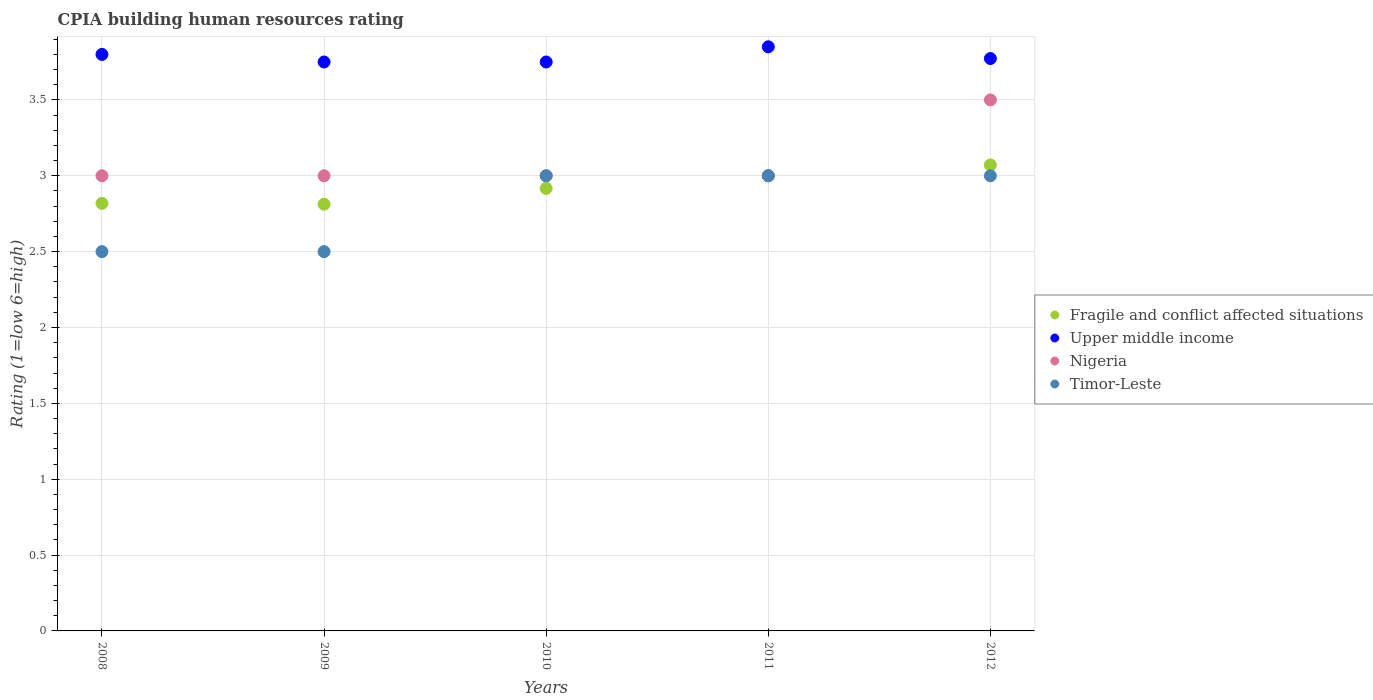How many different coloured dotlines are there?
Offer a very short reply. 4. Across all years, what is the maximum CPIA rating in Fragile and conflict affected situations?
Ensure brevity in your answer.  3.07. In which year was the CPIA rating in Nigeria maximum?
Ensure brevity in your answer.  2012. In which year was the CPIA rating in Timor-Leste minimum?
Your answer should be compact. 2008. What is the difference between the CPIA rating in Upper middle income in 2010 and that in 2012?
Your answer should be compact. -0.02. What is the average CPIA rating in Fragile and conflict affected situations per year?
Your response must be concise. 2.92. In the year 2010, what is the difference between the CPIA rating in Fragile and conflict affected situations and CPIA rating in Timor-Leste?
Provide a short and direct response. -0.08. In how many years, is the CPIA rating in Timor-Leste greater than 1.1?
Make the answer very short. 5. What is the ratio of the CPIA rating in Upper middle income in 2008 to that in 2009?
Provide a succinct answer. 1.01. Is the CPIA rating in Upper middle income in 2009 less than that in 2010?
Ensure brevity in your answer.  No. Is the difference between the CPIA rating in Fragile and conflict affected situations in 2009 and 2011 greater than the difference between the CPIA rating in Timor-Leste in 2009 and 2011?
Your response must be concise. Yes. What is the difference between the highest and the second highest CPIA rating in Fragile and conflict affected situations?
Provide a short and direct response. 0.07. Is it the case that in every year, the sum of the CPIA rating in Upper middle income and CPIA rating in Nigeria  is greater than the sum of CPIA rating in Fragile and conflict affected situations and CPIA rating in Timor-Leste?
Keep it short and to the point. Yes. Is it the case that in every year, the sum of the CPIA rating in Fragile and conflict affected situations and CPIA rating in Nigeria  is greater than the CPIA rating in Timor-Leste?
Provide a short and direct response. Yes. Is the CPIA rating in Upper middle income strictly less than the CPIA rating in Fragile and conflict affected situations over the years?
Ensure brevity in your answer.  No. What is the difference between two consecutive major ticks on the Y-axis?
Provide a short and direct response. 0.5. Does the graph contain grids?
Offer a very short reply. Yes. Where does the legend appear in the graph?
Offer a very short reply. Center right. How are the legend labels stacked?
Your answer should be compact. Vertical. What is the title of the graph?
Ensure brevity in your answer.  CPIA building human resources rating. What is the Rating (1=low 6=high) in Fragile and conflict affected situations in 2008?
Offer a terse response. 2.82. What is the Rating (1=low 6=high) in Nigeria in 2008?
Provide a short and direct response. 3. What is the Rating (1=low 6=high) of Fragile and conflict affected situations in 2009?
Make the answer very short. 2.81. What is the Rating (1=low 6=high) in Upper middle income in 2009?
Offer a very short reply. 3.75. What is the Rating (1=low 6=high) in Nigeria in 2009?
Offer a terse response. 3. What is the Rating (1=low 6=high) in Timor-Leste in 2009?
Provide a short and direct response. 2.5. What is the Rating (1=low 6=high) in Fragile and conflict affected situations in 2010?
Provide a succinct answer. 2.92. What is the Rating (1=low 6=high) of Upper middle income in 2010?
Offer a very short reply. 3.75. What is the Rating (1=low 6=high) of Nigeria in 2010?
Your response must be concise. 3. What is the Rating (1=low 6=high) of Fragile and conflict affected situations in 2011?
Your answer should be very brief. 3. What is the Rating (1=low 6=high) of Upper middle income in 2011?
Give a very brief answer. 3.85. What is the Rating (1=low 6=high) in Nigeria in 2011?
Ensure brevity in your answer.  3. What is the Rating (1=low 6=high) in Fragile and conflict affected situations in 2012?
Provide a short and direct response. 3.07. What is the Rating (1=low 6=high) in Upper middle income in 2012?
Provide a succinct answer. 3.77. What is the Rating (1=low 6=high) in Nigeria in 2012?
Keep it short and to the point. 3.5. What is the Rating (1=low 6=high) in Timor-Leste in 2012?
Keep it short and to the point. 3. Across all years, what is the maximum Rating (1=low 6=high) of Fragile and conflict affected situations?
Ensure brevity in your answer.  3.07. Across all years, what is the maximum Rating (1=low 6=high) in Upper middle income?
Provide a short and direct response. 3.85. Across all years, what is the minimum Rating (1=low 6=high) in Fragile and conflict affected situations?
Keep it short and to the point. 2.81. Across all years, what is the minimum Rating (1=low 6=high) in Upper middle income?
Make the answer very short. 3.75. What is the total Rating (1=low 6=high) in Fragile and conflict affected situations in the graph?
Offer a terse response. 14.62. What is the total Rating (1=low 6=high) of Upper middle income in the graph?
Offer a very short reply. 18.92. What is the total Rating (1=low 6=high) of Timor-Leste in the graph?
Provide a short and direct response. 14. What is the difference between the Rating (1=low 6=high) of Fragile and conflict affected situations in 2008 and that in 2009?
Make the answer very short. 0.01. What is the difference between the Rating (1=low 6=high) of Timor-Leste in 2008 and that in 2009?
Your answer should be very brief. 0. What is the difference between the Rating (1=low 6=high) of Fragile and conflict affected situations in 2008 and that in 2010?
Your answer should be very brief. -0.1. What is the difference between the Rating (1=low 6=high) of Timor-Leste in 2008 and that in 2010?
Offer a very short reply. -0.5. What is the difference between the Rating (1=low 6=high) in Fragile and conflict affected situations in 2008 and that in 2011?
Make the answer very short. -0.18. What is the difference between the Rating (1=low 6=high) in Upper middle income in 2008 and that in 2011?
Keep it short and to the point. -0.05. What is the difference between the Rating (1=low 6=high) in Nigeria in 2008 and that in 2011?
Give a very brief answer. 0. What is the difference between the Rating (1=low 6=high) in Fragile and conflict affected situations in 2008 and that in 2012?
Your response must be concise. -0.25. What is the difference between the Rating (1=low 6=high) in Upper middle income in 2008 and that in 2012?
Your response must be concise. 0.03. What is the difference between the Rating (1=low 6=high) of Nigeria in 2008 and that in 2012?
Offer a terse response. -0.5. What is the difference between the Rating (1=low 6=high) of Timor-Leste in 2008 and that in 2012?
Ensure brevity in your answer.  -0.5. What is the difference between the Rating (1=low 6=high) in Fragile and conflict affected situations in 2009 and that in 2010?
Offer a very short reply. -0.1. What is the difference between the Rating (1=low 6=high) in Fragile and conflict affected situations in 2009 and that in 2011?
Your answer should be compact. -0.19. What is the difference between the Rating (1=low 6=high) of Upper middle income in 2009 and that in 2011?
Provide a short and direct response. -0.1. What is the difference between the Rating (1=low 6=high) in Nigeria in 2009 and that in 2011?
Your answer should be very brief. 0. What is the difference between the Rating (1=low 6=high) in Timor-Leste in 2009 and that in 2011?
Your response must be concise. -0.5. What is the difference between the Rating (1=low 6=high) in Fragile and conflict affected situations in 2009 and that in 2012?
Your answer should be very brief. -0.26. What is the difference between the Rating (1=low 6=high) in Upper middle income in 2009 and that in 2012?
Your answer should be very brief. -0.02. What is the difference between the Rating (1=low 6=high) in Fragile and conflict affected situations in 2010 and that in 2011?
Make the answer very short. -0.08. What is the difference between the Rating (1=low 6=high) of Upper middle income in 2010 and that in 2011?
Your answer should be compact. -0.1. What is the difference between the Rating (1=low 6=high) in Nigeria in 2010 and that in 2011?
Give a very brief answer. 0. What is the difference between the Rating (1=low 6=high) of Timor-Leste in 2010 and that in 2011?
Make the answer very short. 0. What is the difference between the Rating (1=low 6=high) of Fragile and conflict affected situations in 2010 and that in 2012?
Keep it short and to the point. -0.15. What is the difference between the Rating (1=low 6=high) of Upper middle income in 2010 and that in 2012?
Your answer should be compact. -0.02. What is the difference between the Rating (1=low 6=high) in Timor-Leste in 2010 and that in 2012?
Make the answer very short. 0. What is the difference between the Rating (1=low 6=high) of Fragile and conflict affected situations in 2011 and that in 2012?
Your answer should be very brief. -0.07. What is the difference between the Rating (1=low 6=high) of Upper middle income in 2011 and that in 2012?
Offer a terse response. 0.08. What is the difference between the Rating (1=low 6=high) in Timor-Leste in 2011 and that in 2012?
Your response must be concise. 0. What is the difference between the Rating (1=low 6=high) of Fragile and conflict affected situations in 2008 and the Rating (1=low 6=high) of Upper middle income in 2009?
Provide a short and direct response. -0.93. What is the difference between the Rating (1=low 6=high) of Fragile and conflict affected situations in 2008 and the Rating (1=low 6=high) of Nigeria in 2009?
Offer a very short reply. -0.18. What is the difference between the Rating (1=low 6=high) of Fragile and conflict affected situations in 2008 and the Rating (1=low 6=high) of Timor-Leste in 2009?
Offer a terse response. 0.32. What is the difference between the Rating (1=low 6=high) of Nigeria in 2008 and the Rating (1=low 6=high) of Timor-Leste in 2009?
Provide a short and direct response. 0.5. What is the difference between the Rating (1=low 6=high) in Fragile and conflict affected situations in 2008 and the Rating (1=low 6=high) in Upper middle income in 2010?
Offer a very short reply. -0.93. What is the difference between the Rating (1=low 6=high) in Fragile and conflict affected situations in 2008 and the Rating (1=low 6=high) in Nigeria in 2010?
Provide a succinct answer. -0.18. What is the difference between the Rating (1=low 6=high) of Fragile and conflict affected situations in 2008 and the Rating (1=low 6=high) of Timor-Leste in 2010?
Ensure brevity in your answer.  -0.18. What is the difference between the Rating (1=low 6=high) of Upper middle income in 2008 and the Rating (1=low 6=high) of Nigeria in 2010?
Your answer should be very brief. 0.8. What is the difference between the Rating (1=low 6=high) of Nigeria in 2008 and the Rating (1=low 6=high) of Timor-Leste in 2010?
Make the answer very short. 0. What is the difference between the Rating (1=low 6=high) in Fragile and conflict affected situations in 2008 and the Rating (1=low 6=high) in Upper middle income in 2011?
Give a very brief answer. -1.03. What is the difference between the Rating (1=low 6=high) of Fragile and conflict affected situations in 2008 and the Rating (1=low 6=high) of Nigeria in 2011?
Provide a succinct answer. -0.18. What is the difference between the Rating (1=low 6=high) of Fragile and conflict affected situations in 2008 and the Rating (1=low 6=high) of Timor-Leste in 2011?
Ensure brevity in your answer.  -0.18. What is the difference between the Rating (1=low 6=high) of Nigeria in 2008 and the Rating (1=low 6=high) of Timor-Leste in 2011?
Ensure brevity in your answer.  0. What is the difference between the Rating (1=low 6=high) in Fragile and conflict affected situations in 2008 and the Rating (1=low 6=high) in Upper middle income in 2012?
Your answer should be very brief. -0.95. What is the difference between the Rating (1=low 6=high) in Fragile and conflict affected situations in 2008 and the Rating (1=low 6=high) in Nigeria in 2012?
Provide a short and direct response. -0.68. What is the difference between the Rating (1=low 6=high) in Fragile and conflict affected situations in 2008 and the Rating (1=low 6=high) in Timor-Leste in 2012?
Offer a terse response. -0.18. What is the difference between the Rating (1=low 6=high) of Upper middle income in 2008 and the Rating (1=low 6=high) of Timor-Leste in 2012?
Offer a terse response. 0.8. What is the difference between the Rating (1=low 6=high) in Fragile and conflict affected situations in 2009 and the Rating (1=low 6=high) in Upper middle income in 2010?
Ensure brevity in your answer.  -0.94. What is the difference between the Rating (1=low 6=high) of Fragile and conflict affected situations in 2009 and the Rating (1=low 6=high) of Nigeria in 2010?
Provide a succinct answer. -0.19. What is the difference between the Rating (1=low 6=high) of Fragile and conflict affected situations in 2009 and the Rating (1=low 6=high) of Timor-Leste in 2010?
Your answer should be very brief. -0.19. What is the difference between the Rating (1=low 6=high) in Upper middle income in 2009 and the Rating (1=low 6=high) in Timor-Leste in 2010?
Provide a short and direct response. 0.75. What is the difference between the Rating (1=low 6=high) in Fragile and conflict affected situations in 2009 and the Rating (1=low 6=high) in Upper middle income in 2011?
Offer a terse response. -1.04. What is the difference between the Rating (1=low 6=high) of Fragile and conflict affected situations in 2009 and the Rating (1=low 6=high) of Nigeria in 2011?
Offer a terse response. -0.19. What is the difference between the Rating (1=low 6=high) of Fragile and conflict affected situations in 2009 and the Rating (1=low 6=high) of Timor-Leste in 2011?
Offer a very short reply. -0.19. What is the difference between the Rating (1=low 6=high) in Upper middle income in 2009 and the Rating (1=low 6=high) in Nigeria in 2011?
Make the answer very short. 0.75. What is the difference between the Rating (1=low 6=high) in Nigeria in 2009 and the Rating (1=low 6=high) in Timor-Leste in 2011?
Give a very brief answer. 0. What is the difference between the Rating (1=low 6=high) in Fragile and conflict affected situations in 2009 and the Rating (1=low 6=high) in Upper middle income in 2012?
Ensure brevity in your answer.  -0.96. What is the difference between the Rating (1=low 6=high) of Fragile and conflict affected situations in 2009 and the Rating (1=low 6=high) of Nigeria in 2012?
Provide a succinct answer. -0.69. What is the difference between the Rating (1=low 6=high) of Fragile and conflict affected situations in 2009 and the Rating (1=low 6=high) of Timor-Leste in 2012?
Your response must be concise. -0.19. What is the difference between the Rating (1=low 6=high) in Upper middle income in 2009 and the Rating (1=low 6=high) in Timor-Leste in 2012?
Keep it short and to the point. 0.75. What is the difference between the Rating (1=low 6=high) of Nigeria in 2009 and the Rating (1=low 6=high) of Timor-Leste in 2012?
Provide a succinct answer. 0. What is the difference between the Rating (1=low 6=high) in Fragile and conflict affected situations in 2010 and the Rating (1=low 6=high) in Upper middle income in 2011?
Your answer should be compact. -0.93. What is the difference between the Rating (1=low 6=high) in Fragile and conflict affected situations in 2010 and the Rating (1=low 6=high) in Nigeria in 2011?
Ensure brevity in your answer.  -0.08. What is the difference between the Rating (1=low 6=high) of Fragile and conflict affected situations in 2010 and the Rating (1=low 6=high) of Timor-Leste in 2011?
Your answer should be compact. -0.08. What is the difference between the Rating (1=low 6=high) of Upper middle income in 2010 and the Rating (1=low 6=high) of Nigeria in 2011?
Offer a terse response. 0.75. What is the difference between the Rating (1=low 6=high) in Nigeria in 2010 and the Rating (1=low 6=high) in Timor-Leste in 2011?
Provide a succinct answer. 0. What is the difference between the Rating (1=low 6=high) of Fragile and conflict affected situations in 2010 and the Rating (1=low 6=high) of Upper middle income in 2012?
Ensure brevity in your answer.  -0.86. What is the difference between the Rating (1=low 6=high) in Fragile and conflict affected situations in 2010 and the Rating (1=low 6=high) in Nigeria in 2012?
Keep it short and to the point. -0.58. What is the difference between the Rating (1=low 6=high) in Fragile and conflict affected situations in 2010 and the Rating (1=low 6=high) in Timor-Leste in 2012?
Offer a terse response. -0.08. What is the difference between the Rating (1=low 6=high) of Upper middle income in 2010 and the Rating (1=low 6=high) of Nigeria in 2012?
Your answer should be very brief. 0.25. What is the difference between the Rating (1=low 6=high) of Nigeria in 2010 and the Rating (1=low 6=high) of Timor-Leste in 2012?
Your response must be concise. 0. What is the difference between the Rating (1=low 6=high) in Fragile and conflict affected situations in 2011 and the Rating (1=low 6=high) in Upper middle income in 2012?
Give a very brief answer. -0.77. What is the difference between the Rating (1=low 6=high) of Fragile and conflict affected situations in 2011 and the Rating (1=low 6=high) of Nigeria in 2012?
Ensure brevity in your answer.  -0.5. What is the average Rating (1=low 6=high) of Fragile and conflict affected situations per year?
Provide a short and direct response. 2.92. What is the average Rating (1=low 6=high) in Upper middle income per year?
Give a very brief answer. 3.78. What is the average Rating (1=low 6=high) of Nigeria per year?
Provide a succinct answer. 3.1. In the year 2008, what is the difference between the Rating (1=low 6=high) of Fragile and conflict affected situations and Rating (1=low 6=high) of Upper middle income?
Offer a very short reply. -0.98. In the year 2008, what is the difference between the Rating (1=low 6=high) in Fragile and conflict affected situations and Rating (1=low 6=high) in Nigeria?
Provide a short and direct response. -0.18. In the year 2008, what is the difference between the Rating (1=low 6=high) of Fragile and conflict affected situations and Rating (1=low 6=high) of Timor-Leste?
Your response must be concise. 0.32. In the year 2008, what is the difference between the Rating (1=low 6=high) of Upper middle income and Rating (1=low 6=high) of Nigeria?
Provide a short and direct response. 0.8. In the year 2008, what is the difference between the Rating (1=low 6=high) in Nigeria and Rating (1=low 6=high) in Timor-Leste?
Ensure brevity in your answer.  0.5. In the year 2009, what is the difference between the Rating (1=low 6=high) of Fragile and conflict affected situations and Rating (1=low 6=high) of Upper middle income?
Provide a succinct answer. -0.94. In the year 2009, what is the difference between the Rating (1=low 6=high) of Fragile and conflict affected situations and Rating (1=low 6=high) of Nigeria?
Offer a very short reply. -0.19. In the year 2009, what is the difference between the Rating (1=low 6=high) in Fragile and conflict affected situations and Rating (1=low 6=high) in Timor-Leste?
Give a very brief answer. 0.31. In the year 2009, what is the difference between the Rating (1=low 6=high) of Upper middle income and Rating (1=low 6=high) of Timor-Leste?
Offer a terse response. 1.25. In the year 2010, what is the difference between the Rating (1=low 6=high) of Fragile and conflict affected situations and Rating (1=low 6=high) of Upper middle income?
Give a very brief answer. -0.83. In the year 2010, what is the difference between the Rating (1=low 6=high) of Fragile and conflict affected situations and Rating (1=low 6=high) of Nigeria?
Offer a terse response. -0.08. In the year 2010, what is the difference between the Rating (1=low 6=high) of Fragile and conflict affected situations and Rating (1=low 6=high) of Timor-Leste?
Provide a short and direct response. -0.08. In the year 2011, what is the difference between the Rating (1=low 6=high) of Fragile and conflict affected situations and Rating (1=low 6=high) of Upper middle income?
Your response must be concise. -0.85. In the year 2011, what is the difference between the Rating (1=low 6=high) of Fragile and conflict affected situations and Rating (1=low 6=high) of Nigeria?
Give a very brief answer. 0. In the year 2011, what is the difference between the Rating (1=low 6=high) in Upper middle income and Rating (1=low 6=high) in Timor-Leste?
Provide a short and direct response. 0.85. In the year 2011, what is the difference between the Rating (1=low 6=high) of Nigeria and Rating (1=low 6=high) of Timor-Leste?
Your response must be concise. 0. In the year 2012, what is the difference between the Rating (1=low 6=high) in Fragile and conflict affected situations and Rating (1=low 6=high) in Upper middle income?
Your answer should be compact. -0.7. In the year 2012, what is the difference between the Rating (1=low 6=high) of Fragile and conflict affected situations and Rating (1=low 6=high) of Nigeria?
Provide a short and direct response. -0.43. In the year 2012, what is the difference between the Rating (1=low 6=high) of Fragile and conflict affected situations and Rating (1=low 6=high) of Timor-Leste?
Your response must be concise. 0.07. In the year 2012, what is the difference between the Rating (1=low 6=high) of Upper middle income and Rating (1=low 6=high) of Nigeria?
Your answer should be compact. 0.27. In the year 2012, what is the difference between the Rating (1=low 6=high) of Upper middle income and Rating (1=low 6=high) of Timor-Leste?
Offer a very short reply. 0.77. In the year 2012, what is the difference between the Rating (1=low 6=high) of Nigeria and Rating (1=low 6=high) of Timor-Leste?
Offer a very short reply. 0.5. What is the ratio of the Rating (1=low 6=high) in Upper middle income in 2008 to that in 2009?
Ensure brevity in your answer.  1.01. What is the ratio of the Rating (1=low 6=high) in Fragile and conflict affected situations in 2008 to that in 2010?
Ensure brevity in your answer.  0.97. What is the ratio of the Rating (1=low 6=high) of Upper middle income in 2008 to that in 2010?
Offer a terse response. 1.01. What is the ratio of the Rating (1=low 6=high) in Fragile and conflict affected situations in 2008 to that in 2011?
Make the answer very short. 0.94. What is the ratio of the Rating (1=low 6=high) of Fragile and conflict affected situations in 2008 to that in 2012?
Offer a terse response. 0.92. What is the ratio of the Rating (1=low 6=high) in Upper middle income in 2008 to that in 2012?
Make the answer very short. 1.01. What is the ratio of the Rating (1=low 6=high) of Nigeria in 2008 to that in 2012?
Your answer should be very brief. 0.86. What is the ratio of the Rating (1=low 6=high) of Fragile and conflict affected situations in 2009 to that in 2010?
Give a very brief answer. 0.96. What is the ratio of the Rating (1=low 6=high) in Upper middle income in 2009 to that in 2010?
Offer a terse response. 1. What is the ratio of the Rating (1=low 6=high) of Nigeria in 2009 to that in 2010?
Offer a very short reply. 1. What is the ratio of the Rating (1=low 6=high) in Upper middle income in 2009 to that in 2011?
Provide a short and direct response. 0.97. What is the ratio of the Rating (1=low 6=high) in Nigeria in 2009 to that in 2011?
Keep it short and to the point. 1. What is the ratio of the Rating (1=low 6=high) in Fragile and conflict affected situations in 2009 to that in 2012?
Offer a terse response. 0.92. What is the ratio of the Rating (1=low 6=high) of Fragile and conflict affected situations in 2010 to that in 2011?
Offer a terse response. 0.97. What is the ratio of the Rating (1=low 6=high) in Nigeria in 2010 to that in 2011?
Provide a succinct answer. 1. What is the ratio of the Rating (1=low 6=high) of Timor-Leste in 2010 to that in 2011?
Keep it short and to the point. 1. What is the ratio of the Rating (1=low 6=high) of Fragile and conflict affected situations in 2010 to that in 2012?
Your answer should be very brief. 0.95. What is the ratio of the Rating (1=low 6=high) in Fragile and conflict affected situations in 2011 to that in 2012?
Your response must be concise. 0.98. What is the ratio of the Rating (1=low 6=high) of Upper middle income in 2011 to that in 2012?
Ensure brevity in your answer.  1.02. What is the ratio of the Rating (1=low 6=high) of Nigeria in 2011 to that in 2012?
Ensure brevity in your answer.  0.86. What is the difference between the highest and the second highest Rating (1=low 6=high) in Fragile and conflict affected situations?
Your answer should be compact. 0.07. What is the difference between the highest and the second highest Rating (1=low 6=high) of Upper middle income?
Ensure brevity in your answer.  0.05. What is the difference between the highest and the second highest Rating (1=low 6=high) of Nigeria?
Your answer should be compact. 0.5. What is the difference between the highest and the second highest Rating (1=low 6=high) of Timor-Leste?
Make the answer very short. 0. What is the difference between the highest and the lowest Rating (1=low 6=high) in Fragile and conflict affected situations?
Your answer should be very brief. 0.26. What is the difference between the highest and the lowest Rating (1=low 6=high) in Nigeria?
Give a very brief answer. 0.5. 